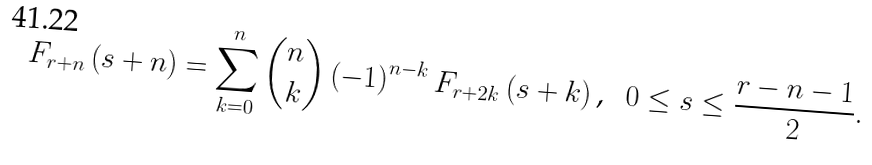Convert formula to latex. <formula><loc_0><loc_0><loc_500><loc_500>F _ { r + n } \left ( s + n \right ) = \sum _ { k = 0 } ^ { n } \binom { n } { k } \left ( - 1 \right ) ^ { n - k } F _ { r + 2 k } \left ( s + k \right ) \text {, \ \ } 0 \leq s \leq \frac { r - n - 1 } { 2 } .</formula> 